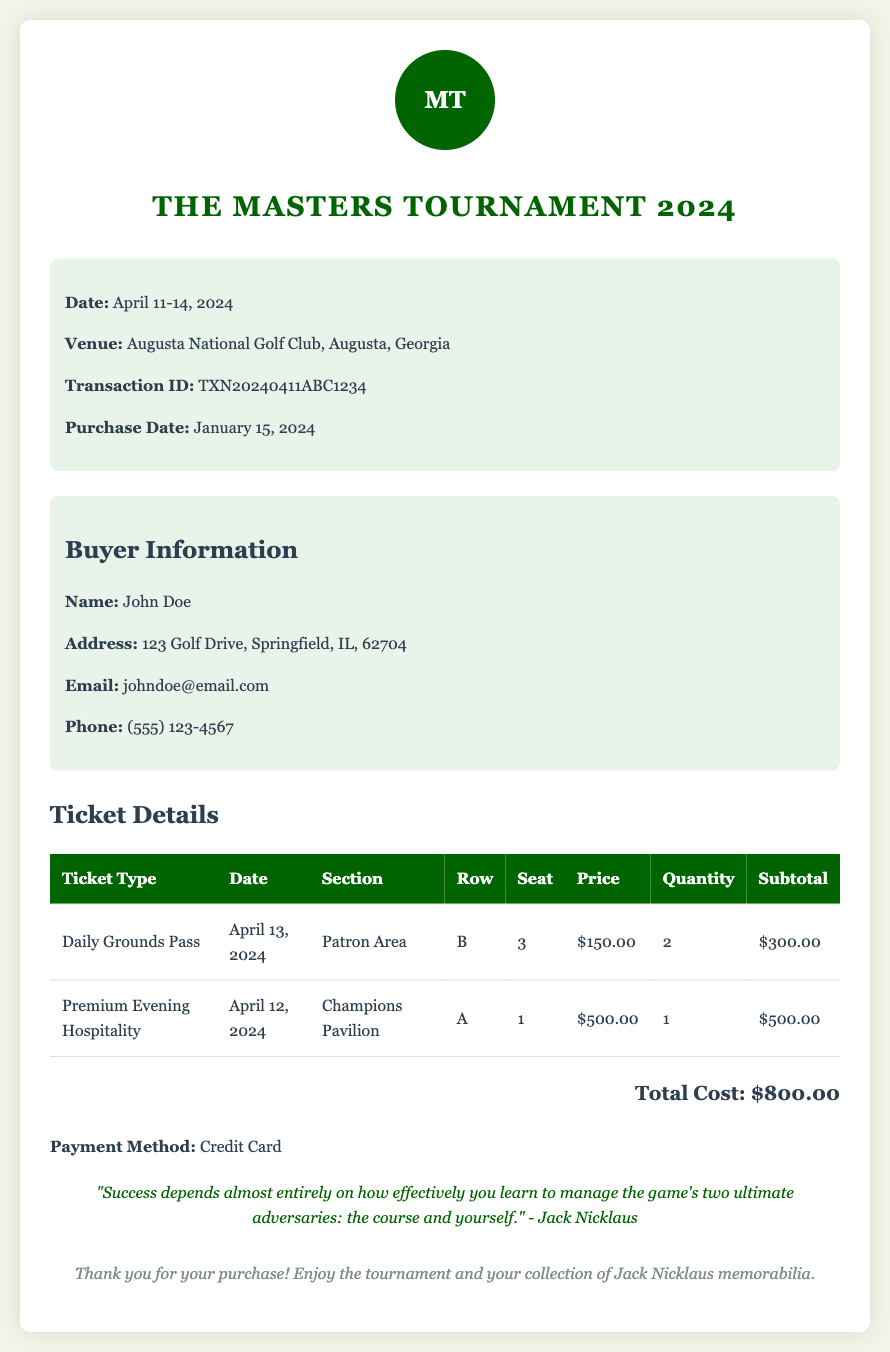What is the transaction ID? The transaction ID is a unique identifier for this purchase found in the document.
Answer: TXN20240411ABC1234 What is the date of the tournament? The date of the tournament is mentioned clearly in the document.
Answer: April 11-14, 2024 How much is the price of a Daily Grounds Pass? The price of the Daily Grounds Pass is provided in the ticket details section.
Answer: $150.00 What is the total cost of the tickets? The total cost is a summary of all ticket purchases listed in the document.
Answer: $800.00 How many Daily Grounds Passes were purchased? The number of Daily Grounds Passes purchased can be found in the ticket details section.
Answer: 2 Where will the Premium Evening Hospitality take place? The location for the Premium Evening Hospitality is specified in the document.
Answer: Champions Pavilion Who is the buyer's name? The buyer's name is provided under the buyer information section of the document.
Answer: John Doe What payment method was used? The payment method used for the transaction is stated in the document.
Answer: Credit Card Which section are the purchased Daily Grounds Passes located? The section for the Daily Grounds Passes is listed in the ticket details.
Answer: Patron Area 